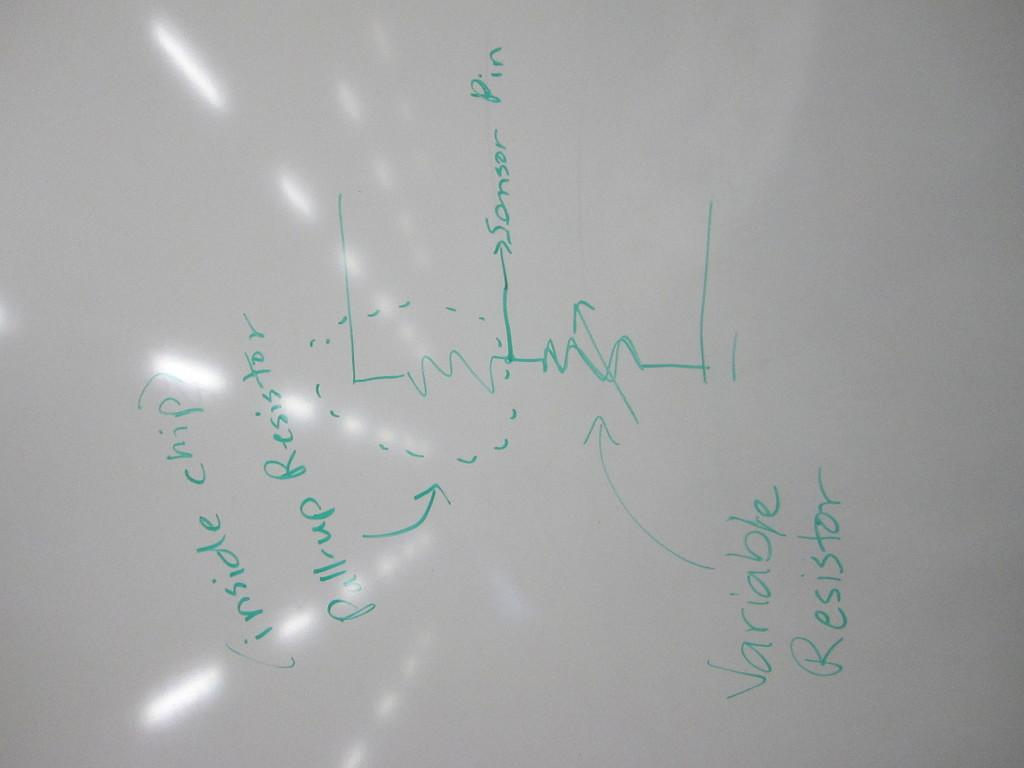Provide a one-sentence caption for the provided image. A graph showing several variable including Variable Resistor. 